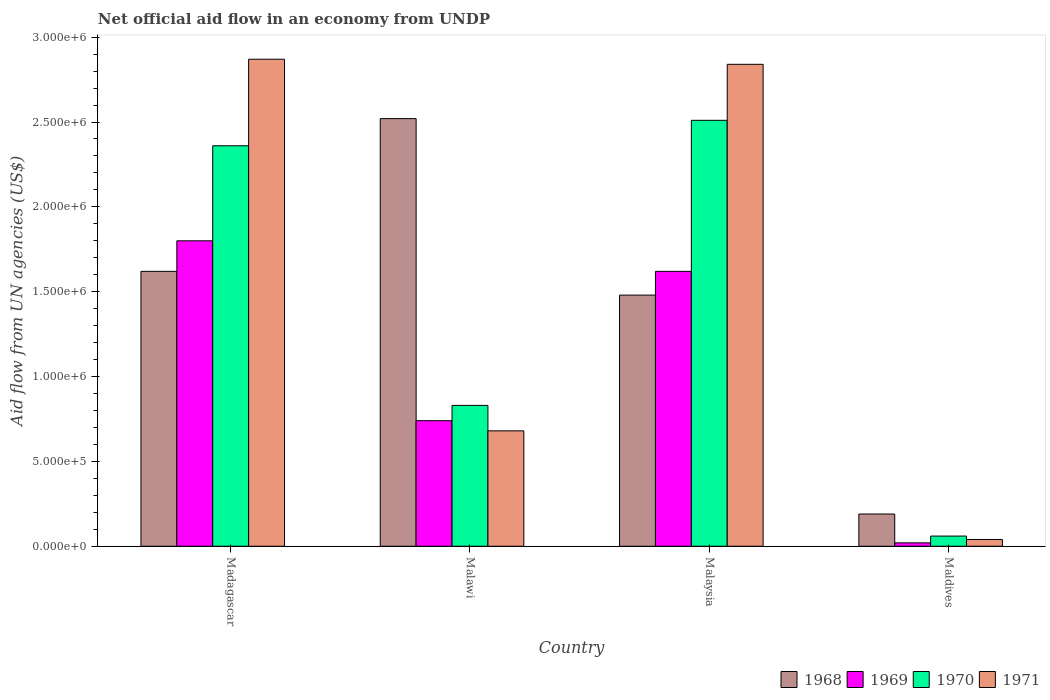How many different coloured bars are there?
Provide a succinct answer. 4. How many groups of bars are there?
Make the answer very short. 4. Are the number of bars per tick equal to the number of legend labels?
Keep it short and to the point. Yes. Are the number of bars on each tick of the X-axis equal?
Your answer should be very brief. Yes. How many bars are there on the 4th tick from the left?
Ensure brevity in your answer.  4. What is the label of the 3rd group of bars from the left?
Give a very brief answer. Malaysia. In how many cases, is the number of bars for a given country not equal to the number of legend labels?
Ensure brevity in your answer.  0. What is the net official aid flow in 1970 in Madagascar?
Your response must be concise. 2.36e+06. Across all countries, what is the maximum net official aid flow in 1969?
Provide a succinct answer. 1.80e+06. Across all countries, what is the minimum net official aid flow in 1969?
Your response must be concise. 2.00e+04. In which country was the net official aid flow in 1968 maximum?
Keep it short and to the point. Malawi. In which country was the net official aid flow in 1969 minimum?
Make the answer very short. Maldives. What is the total net official aid flow in 1968 in the graph?
Give a very brief answer. 5.81e+06. What is the difference between the net official aid flow in 1968 in Malawi and that in Maldives?
Make the answer very short. 2.33e+06. What is the difference between the net official aid flow in 1969 in Madagascar and the net official aid flow in 1971 in Maldives?
Provide a short and direct response. 1.76e+06. What is the average net official aid flow in 1968 per country?
Your answer should be very brief. 1.45e+06. What is the ratio of the net official aid flow in 1970 in Madagascar to that in Malawi?
Provide a succinct answer. 2.84. What is the difference between the highest and the second highest net official aid flow in 1970?
Your answer should be compact. 1.68e+06. What is the difference between the highest and the lowest net official aid flow in 1969?
Ensure brevity in your answer.  1.78e+06. What does the 3rd bar from the right in Malawi represents?
Keep it short and to the point. 1969. Is it the case that in every country, the sum of the net official aid flow in 1968 and net official aid flow in 1969 is greater than the net official aid flow in 1970?
Keep it short and to the point. Yes. What is the difference between two consecutive major ticks on the Y-axis?
Your answer should be very brief. 5.00e+05. Are the values on the major ticks of Y-axis written in scientific E-notation?
Keep it short and to the point. Yes. Does the graph contain grids?
Give a very brief answer. No. What is the title of the graph?
Ensure brevity in your answer.  Net official aid flow in an economy from UNDP. What is the label or title of the X-axis?
Offer a terse response. Country. What is the label or title of the Y-axis?
Your answer should be compact. Aid flow from UN agencies (US$). What is the Aid flow from UN agencies (US$) of 1968 in Madagascar?
Provide a short and direct response. 1.62e+06. What is the Aid flow from UN agencies (US$) of 1969 in Madagascar?
Your answer should be compact. 1.80e+06. What is the Aid flow from UN agencies (US$) of 1970 in Madagascar?
Give a very brief answer. 2.36e+06. What is the Aid flow from UN agencies (US$) of 1971 in Madagascar?
Your answer should be very brief. 2.87e+06. What is the Aid flow from UN agencies (US$) of 1968 in Malawi?
Keep it short and to the point. 2.52e+06. What is the Aid flow from UN agencies (US$) of 1969 in Malawi?
Ensure brevity in your answer.  7.40e+05. What is the Aid flow from UN agencies (US$) of 1970 in Malawi?
Provide a succinct answer. 8.30e+05. What is the Aid flow from UN agencies (US$) of 1971 in Malawi?
Ensure brevity in your answer.  6.80e+05. What is the Aid flow from UN agencies (US$) in 1968 in Malaysia?
Provide a short and direct response. 1.48e+06. What is the Aid flow from UN agencies (US$) of 1969 in Malaysia?
Provide a succinct answer. 1.62e+06. What is the Aid flow from UN agencies (US$) of 1970 in Malaysia?
Give a very brief answer. 2.51e+06. What is the Aid flow from UN agencies (US$) of 1971 in Malaysia?
Offer a terse response. 2.84e+06. What is the Aid flow from UN agencies (US$) in 1970 in Maldives?
Provide a succinct answer. 6.00e+04. What is the Aid flow from UN agencies (US$) of 1971 in Maldives?
Offer a very short reply. 4.00e+04. Across all countries, what is the maximum Aid flow from UN agencies (US$) in 1968?
Your answer should be very brief. 2.52e+06. Across all countries, what is the maximum Aid flow from UN agencies (US$) of 1969?
Offer a very short reply. 1.80e+06. Across all countries, what is the maximum Aid flow from UN agencies (US$) in 1970?
Offer a very short reply. 2.51e+06. Across all countries, what is the maximum Aid flow from UN agencies (US$) of 1971?
Offer a very short reply. 2.87e+06. Across all countries, what is the minimum Aid flow from UN agencies (US$) in 1969?
Offer a very short reply. 2.00e+04. Across all countries, what is the minimum Aid flow from UN agencies (US$) of 1971?
Make the answer very short. 4.00e+04. What is the total Aid flow from UN agencies (US$) in 1968 in the graph?
Keep it short and to the point. 5.81e+06. What is the total Aid flow from UN agencies (US$) of 1969 in the graph?
Ensure brevity in your answer.  4.18e+06. What is the total Aid flow from UN agencies (US$) in 1970 in the graph?
Provide a short and direct response. 5.76e+06. What is the total Aid flow from UN agencies (US$) in 1971 in the graph?
Offer a very short reply. 6.43e+06. What is the difference between the Aid flow from UN agencies (US$) in 1968 in Madagascar and that in Malawi?
Your answer should be compact. -9.00e+05. What is the difference between the Aid flow from UN agencies (US$) in 1969 in Madagascar and that in Malawi?
Provide a succinct answer. 1.06e+06. What is the difference between the Aid flow from UN agencies (US$) in 1970 in Madagascar and that in Malawi?
Ensure brevity in your answer.  1.53e+06. What is the difference between the Aid flow from UN agencies (US$) of 1971 in Madagascar and that in Malawi?
Your response must be concise. 2.19e+06. What is the difference between the Aid flow from UN agencies (US$) of 1969 in Madagascar and that in Malaysia?
Your answer should be very brief. 1.80e+05. What is the difference between the Aid flow from UN agencies (US$) in 1970 in Madagascar and that in Malaysia?
Keep it short and to the point. -1.50e+05. What is the difference between the Aid flow from UN agencies (US$) of 1968 in Madagascar and that in Maldives?
Your answer should be very brief. 1.43e+06. What is the difference between the Aid flow from UN agencies (US$) of 1969 in Madagascar and that in Maldives?
Offer a very short reply. 1.78e+06. What is the difference between the Aid flow from UN agencies (US$) in 1970 in Madagascar and that in Maldives?
Give a very brief answer. 2.30e+06. What is the difference between the Aid flow from UN agencies (US$) of 1971 in Madagascar and that in Maldives?
Give a very brief answer. 2.83e+06. What is the difference between the Aid flow from UN agencies (US$) of 1968 in Malawi and that in Malaysia?
Ensure brevity in your answer.  1.04e+06. What is the difference between the Aid flow from UN agencies (US$) in 1969 in Malawi and that in Malaysia?
Your answer should be very brief. -8.80e+05. What is the difference between the Aid flow from UN agencies (US$) in 1970 in Malawi and that in Malaysia?
Make the answer very short. -1.68e+06. What is the difference between the Aid flow from UN agencies (US$) of 1971 in Malawi and that in Malaysia?
Provide a short and direct response. -2.16e+06. What is the difference between the Aid flow from UN agencies (US$) of 1968 in Malawi and that in Maldives?
Your answer should be very brief. 2.33e+06. What is the difference between the Aid flow from UN agencies (US$) in 1969 in Malawi and that in Maldives?
Make the answer very short. 7.20e+05. What is the difference between the Aid flow from UN agencies (US$) of 1970 in Malawi and that in Maldives?
Give a very brief answer. 7.70e+05. What is the difference between the Aid flow from UN agencies (US$) of 1971 in Malawi and that in Maldives?
Provide a succinct answer. 6.40e+05. What is the difference between the Aid flow from UN agencies (US$) in 1968 in Malaysia and that in Maldives?
Offer a terse response. 1.29e+06. What is the difference between the Aid flow from UN agencies (US$) in 1969 in Malaysia and that in Maldives?
Provide a succinct answer. 1.60e+06. What is the difference between the Aid flow from UN agencies (US$) in 1970 in Malaysia and that in Maldives?
Your response must be concise. 2.45e+06. What is the difference between the Aid flow from UN agencies (US$) of 1971 in Malaysia and that in Maldives?
Your answer should be very brief. 2.80e+06. What is the difference between the Aid flow from UN agencies (US$) in 1968 in Madagascar and the Aid flow from UN agencies (US$) in 1969 in Malawi?
Offer a terse response. 8.80e+05. What is the difference between the Aid flow from UN agencies (US$) in 1968 in Madagascar and the Aid flow from UN agencies (US$) in 1970 in Malawi?
Your response must be concise. 7.90e+05. What is the difference between the Aid flow from UN agencies (US$) in 1968 in Madagascar and the Aid flow from UN agencies (US$) in 1971 in Malawi?
Your answer should be compact. 9.40e+05. What is the difference between the Aid flow from UN agencies (US$) in 1969 in Madagascar and the Aid flow from UN agencies (US$) in 1970 in Malawi?
Your answer should be compact. 9.70e+05. What is the difference between the Aid flow from UN agencies (US$) of 1969 in Madagascar and the Aid flow from UN agencies (US$) of 1971 in Malawi?
Make the answer very short. 1.12e+06. What is the difference between the Aid flow from UN agencies (US$) in 1970 in Madagascar and the Aid flow from UN agencies (US$) in 1971 in Malawi?
Offer a terse response. 1.68e+06. What is the difference between the Aid flow from UN agencies (US$) in 1968 in Madagascar and the Aid flow from UN agencies (US$) in 1969 in Malaysia?
Your answer should be very brief. 0. What is the difference between the Aid flow from UN agencies (US$) in 1968 in Madagascar and the Aid flow from UN agencies (US$) in 1970 in Malaysia?
Give a very brief answer. -8.90e+05. What is the difference between the Aid flow from UN agencies (US$) in 1968 in Madagascar and the Aid flow from UN agencies (US$) in 1971 in Malaysia?
Your response must be concise. -1.22e+06. What is the difference between the Aid flow from UN agencies (US$) in 1969 in Madagascar and the Aid flow from UN agencies (US$) in 1970 in Malaysia?
Make the answer very short. -7.10e+05. What is the difference between the Aid flow from UN agencies (US$) in 1969 in Madagascar and the Aid flow from UN agencies (US$) in 1971 in Malaysia?
Your response must be concise. -1.04e+06. What is the difference between the Aid flow from UN agencies (US$) in 1970 in Madagascar and the Aid flow from UN agencies (US$) in 1971 in Malaysia?
Provide a short and direct response. -4.80e+05. What is the difference between the Aid flow from UN agencies (US$) of 1968 in Madagascar and the Aid flow from UN agencies (US$) of 1969 in Maldives?
Keep it short and to the point. 1.60e+06. What is the difference between the Aid flow from UN agencies (US$) of 1968 in Madagascar and the Aid flow from UN agencies (US$) of 1970 in Maldives?
Provide a succinct answer. 1.56e+06. What is the difference between the Aid flow from UN agencies (US$) of 1968 in Madagascar and the Aid flow from UN agencies (US$) of 1971 in Maldives?
Ensure brevity in your answer.  1.58e+06. What is the difference between the Aid flow from UN agencies (US$) in 1969 in Madagascar and the Aid flow from UN agencies (US$) in 1970 in Maldives?
Your answer should be very brief. 1.74e+06. What is the difference between the Aid flow from UN agencies (US$) in 1969 in Madagascar and the Aid flow from UN agencies (US$) in 1971 in Maldives?
Your answer should be very brief. 1.76e+06. What is the difference between the Aid flow from UN agencies (US$) of 1970 in Madagascar and the Aid flow from UN agencies (US$) of 1971 in Maldives?
Provide a short and direct response. 2.32e+06. What is the difference between the Aid flow from UN agencies (US$) of 1968 in Malawi and the Aid flow from UN agencies (US$) of 1971 in Malaysia?
Keep it short and to the point. -3.20e+05. What is the difference between the Aid flow from UN agencies (US$) of 1969 in Malawi and the Aid flow from UN agencies (US$) of 1970 in Malaysia?
Ensure brevity in your answer.  -1.77e+06. What is the difference between the Aid flow from UN agencies (US$) in 1969 in Malawi and the Aid flow from UN agencies (US$) in 1971 in Malaysia?
Provide a short and direct response. -2.10e+06. What is the difference between the Aid flow from UN agencies (US$) of 1970 in Malawi and the Aid flow from UN agencies (US$) of 1971 in Malaysia?
Provide a succinct answer. -2.01e+06. What is the difference between the Aid flow from UN agencies (US$) in 1968 in Malawi and the Aid flow from UN agencies (US$) in 1969 in Maldives?
Your answer should be very brief. 2.50e+06. What is the difference between the Aid flow from UN agencies (US$) in 1968 in Malawi and the Aid flow from UN agencies (US$) in 1970 in Maldives?
Offer a very short reply. 2.46e+06. What is the difference between the Aid flow from UN agencies (US$) of 1968 in Malawi and the Aid flow from UN agencies (US$) of 1971 in Maldives?
Ensure brevity in your answer.  2.48e+06. What is the difference between the Aid flow from UN agencies (US$) in 1969 in Malawi and the Aid flow from UN agencies (US$) in 1970 in Maldives?
Provide a succinct answer. 6.80e+05. What is the difference between the Aid flow from UN agencies (US$) in 1970 in Malawi and the Aid flow from UN agencies (US$) in 1971 in Maldives?
Provide a short and direct response. 7.90e+05. What is the difference between the Aid flow from UN agencies (US$) in 1968 in Malaysia and the Aid flow from UN agencies (US$) in 1969 in Maldives?
Make the answer very short. 1.46e+06. What is the difference between the Aid flow from UN agencies (US$) in 1968 in Malaysia and the Aid flow from UN agencies (US$) in 1970 in Maldives?
Provide a short and direct response. 1.42e+06. What is the difference between the Aid flow from UN agencies (US$) in 1968 in Malaysia and the Aid flow from UN agencies (US$) in 1971 in Maldives?
Keep it short and to the point. 1.44e+06. What is the difference between the Aid flow from UN agencies (US$) in 1969 in Malaysia and the Aid flow from UN agencies (US$) in 1970 in Maldives?
Offer a terse response. 1.56e+06. What is the difference between the Aid flow from UN agencies (US$) in 1969 in Malaysia and the Aid flow from UN agencies (US$) in 1971 in Maldives?
Your answer should be compact. 1.58e+06. What is the difference between the Aid flow from UN agencies (US$) of 1970 in Malaysia and the Aid flow from UN agencies (US$) of 1971 in Maldives?
Provide a short and direct response. 2.47e+06. What is the average Aid flow from UN agencies (US$) in 1968 per country?
Offer a very short reply. 1.45e+06. What is the average Aid flow from UN agencies (US$) in 1969 per country?
Give a very brief answer. 1.04e+06. What is the average Aid flow from UN agencies (US$) in 1970 per country?
Provide a short and direct response. 1.44e+06. What is the average Aid flow from UN agencies (US$) of 1971 per country?
Offer a terse response. 1.61e+06. What is the difference between the Aid flow from UN agencies (US$) of 1968 and Aid flow from UN agencies (US$) of 1969 in Madagascar?
Your response must be concise. -1.80e+05. What is the difference between the Aid flow from UN agencies (US$) of 1968 and Aid flow from UN agencies (US$) of 1970 in Madagascar?
Provide a short and direct response. -7.40e+05. What is the difference between the Aid flow from UN agencies (US$) in 1968 and Aid flow from UN agencies (US$) in 1971 in Madagascar?
Keep it short and to the point. -1.25e+06. What is the difference between the Aid flow from UN agencies (US$) of 1969 and Aid flow from UN agencies (US$) of 1970 in Madagascar?
Provide a short and direct response. -5.60e+05. What is the difference between the Aid flow from UN agencies (US$) of 1969 and Aid flow from UN agencies (US$) of 1971 in Madagascar?
Ensure brevity in your answer.  -1.07e+06. What is the difference between the Aid flow from UN agencies (US$) in 1970 and Aid flow from UN agencies (US$) in 1971 in Madagascar?
Keep it short and to the point. -5.10e+05. What is the difference between the Aid flow from UN agencies (US$) of 1968 and Aid flow from UN agencies (US$) of 1969 in Malawi?
Make the answer very short. 1.78e+06. What is the difference between the Aid flow from UN agencies (US$) in 1968 and Aid flow from UN agencies (US$) in 1970 in Malawi?
Offer a very short reply. 1.69e+06. What is the difference between the Aid flow from UN agencies (US$) of 1968 and Aid flow from UN agencies (US$) of 1971 in Malawi?
Make the answer very short. 1.84e+06. What is the difference between the Aid flow from UN agencies (US$) in 1969 and Aid flow from UN agencies (US$) in 1970 in Malawi?
Your answer should be very brief. -9.00e+04. What is the difference between the Aid flow from UN agencies (US$) in 1969 and Aid flow from UN agencies (US$) in 1971 in Malawi?
Your response must be concise. 6.00e+04. What is the difference between the Aid flow from UN agencies (US$) of 1970 and Aid flow from UN agencies (US$) of 1971 in Malawi?
Offer a very short reply. 1.50e+05. What is the difference between the Aid flow from UN agencies (US$) in 1968 and Aid flow from UN agencies (US$) in 1970 in Malaysia?
Offer a terse response. -1.03e+06. What is the difference between the Aid flow from UN agencies (US$) of 1968 and Aid flow from UN agencies (US$) of 1971 in Malaysia?
Give a very brief answer. -1.36e+06. What is the difference between the Aid flow from UN agencies (US$) in 1969 and Aid flow from UN agencies (US$) in 1970 in Malaysia?
Keep it short and to the point. -8.90e+05. What is the difference between the Aid flow from UN agencies (US$) in 1969 and Aid flow from UN agencies (US$) in 1971 in Malaysia?
Give a very brief answer. -1.22e+06. What is the difference between the Aid flow from UN agencies (US$) in 1970 and Aid flow from UN agencies (US$) in 1971 in Malaysia?
Ensure brevity in your answer.  -3.30e+05. What is the difference between the Aid flow from UN agencies (US$) of 1968 and Aid flow from UN agencies (US$) of 1969 in Maldives?
Make the answer very short. 1.70e+05. What is the difference between the Aid flow from UN agencies (US$) in 1969 and Aid flow from UN agencies (US$) in 1971 in Maldives?
Provide a succinct answer. -2.00e+04. What is the ratio of the Aid flow from UN agencies (US$) in 1968 in Madagascar to that in Malawi?
Make the answer very short. 0.64. What is the ratio of the Aid flow from UN agencies (US$) of 1969 in Madagascar to that in Malawi?
Your answer should be very brief. 2.43. What is the ratio of the Aid flow from UN agencies (US$) in 1970 in Madagascar to that in Malawi?
Ensure brevity in your answer.  2.84. What is the ratio of the Aid flow from UN agencies (US$) in 1971 in Madagascar to that in Malawi?
Keep it short and to the point. 4.22. What is the ratio of the Aid flow from UN agencies (US$) of 1968 in Madagascar to that in Malaysia?
Give a very brief answer. 1.09. What is the ratio of the Aid flow from UN agencies (US$) in 1970 in Madagascar to that in Malaysia?
Keep it short and to the point. 0.94. What is the ratio of the Aid flow from UN agencies (US$) of 1971 in Madagascar to that in Malaysia?
Ensure brevity in your answer.  1.01. What is the ratio of the Aid flow from UN agencies (US$) of 1968 in Madagascar to that in Maldives?
Ensure brevity in your answer.  8.53. What is the ratio of the Aid flow from UN agencies (US$) of 1969 in Madagascar to that in Maldives?
Give a very brief answer. 90. What is the ratio of the Aid flow from UN agencies (US$) of 1970 in Madagascar to that in Maldives?
Make the answer very short. 39.33. What is the ratio of the Aid flow from UN agencies (US$) of 1971 in Madagascar to that in Maldives?
Ensure brevity in your answer.  71.75. What is the ratio of the Aid flow from UN agencies (US$) of 1968 in Malawi to that in Malaysia?
Give a very brief answer. 1.7. What is the ratio of the Aid flow from UN agencies (US$) in 1969 in Malawi to that in Malaysia?
Ensure brevity in your answer.  0.46. What is the ratio of the Aid flow from UN agencies (US$) in 1970 in Malawi to that in Malaysia?
Offer a very short reply. 0.33. What is the ratio of the Aid flow from UN agencies (US$) in 1971 in Malawi to that in Malaysia?
Your answer should be compact. 0.24. What is the ratio of the Aid flow from UN agencies (US$) of 1968 in Malawi to that in Maldives?
Keep it short and to the point. 13.26. What is the ratio of the Aid flow from UN agencies (US$) of 1969 in Malawi to that in Maldives?
Offer a very short reply. 37. What is the ratio of the Aid flow from UN agencies (US$) in 1970 in Malawi to that in Maldives?
Ensure brevity in your answer.  13.83. What is the ratio of the Aid flow from UN agencies (US$) of 1968 in Malaysia to that in Maldives?
Make the answer very short. 7.79. What is the ratio of the Aid flow from UN agencies (US$) of 1970 in Malaysia to that in Maldives?
Your response must be concise. 41.83. What is the difference between the highest and the second highest Aid flow from UN agencies (US$) in 1968?
Give a very brief answer. 9.00e+05. What is the difference between the highest and the second highest Aid flow from UN agencies (US$) in 1970?
Keep it short and to the point. 1.50e+05. What is the difference between the highest and the second highest Aid flow from UN agencies (US$) of 1971?
Your answer should be compact. 3.00e+04. What is the difference between the highest and the lowest Aid flow from UN agencies (US$) in 1968?
Your response must be concise. 2.33e+06. What is the difference between the highest and the lowest Aid flow from UN agencies (US$) of 1969?
Your answer should be compact. 1.78e+06. What is the difference between the highest and the lowest Aid flow from UN agencies (US$) of 1970?
Provide a short and direct response. 2.45e+06. What is the difference between the highest and the lowest Aid flow from UN agencies (US$) of 1971?
Ensure brevity in your answer.  2.83e+06. 